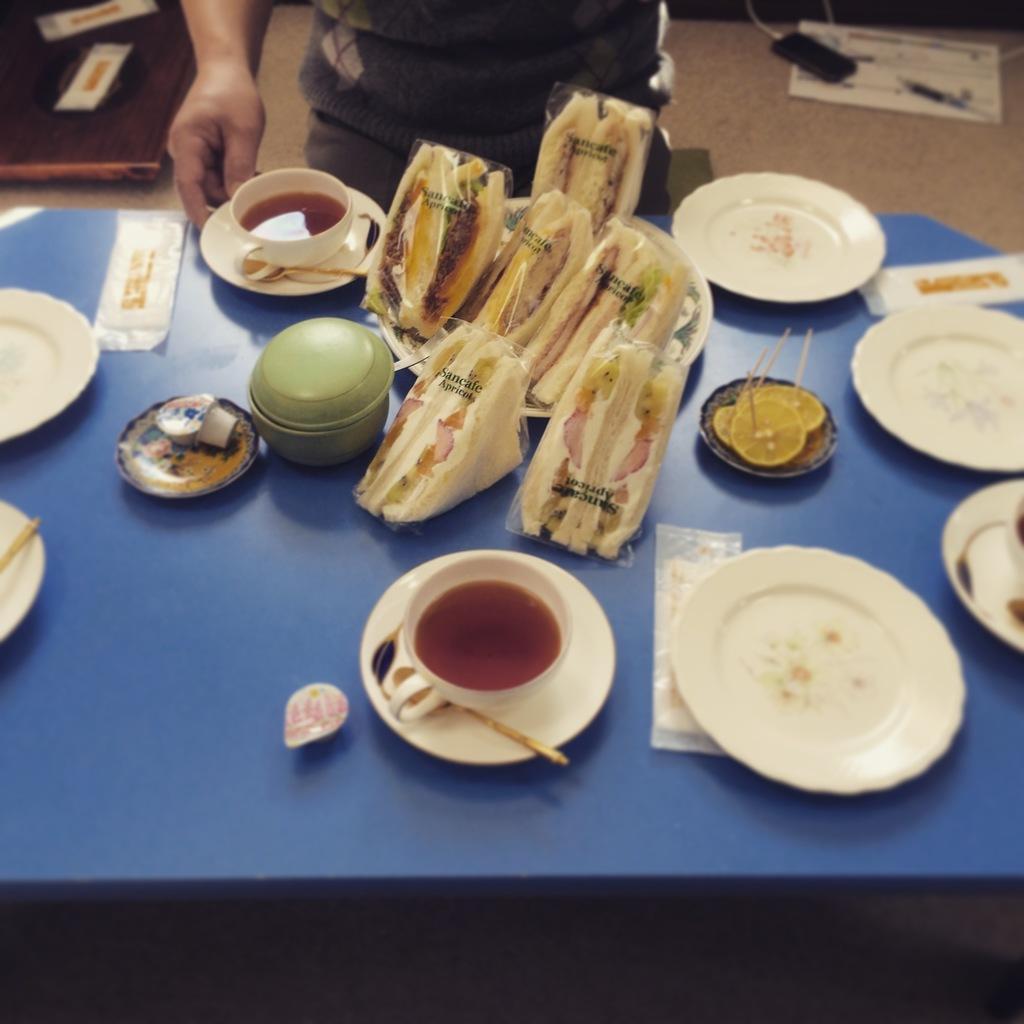In one or two sentences, can you explain what this image depicts? In this image I can see a person is standing and in front of him I can see a blue colored table and on it I can see few plates, few cups and few sandwiches on the plate. I can see a mobile, a paper and few other objects on the floor. 